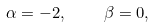Convert formula to latex. <formula><loc_0><loc_0><loc_500><loc_500>\alpha = - 2 , \quad \beta = 0 ,</formula> 